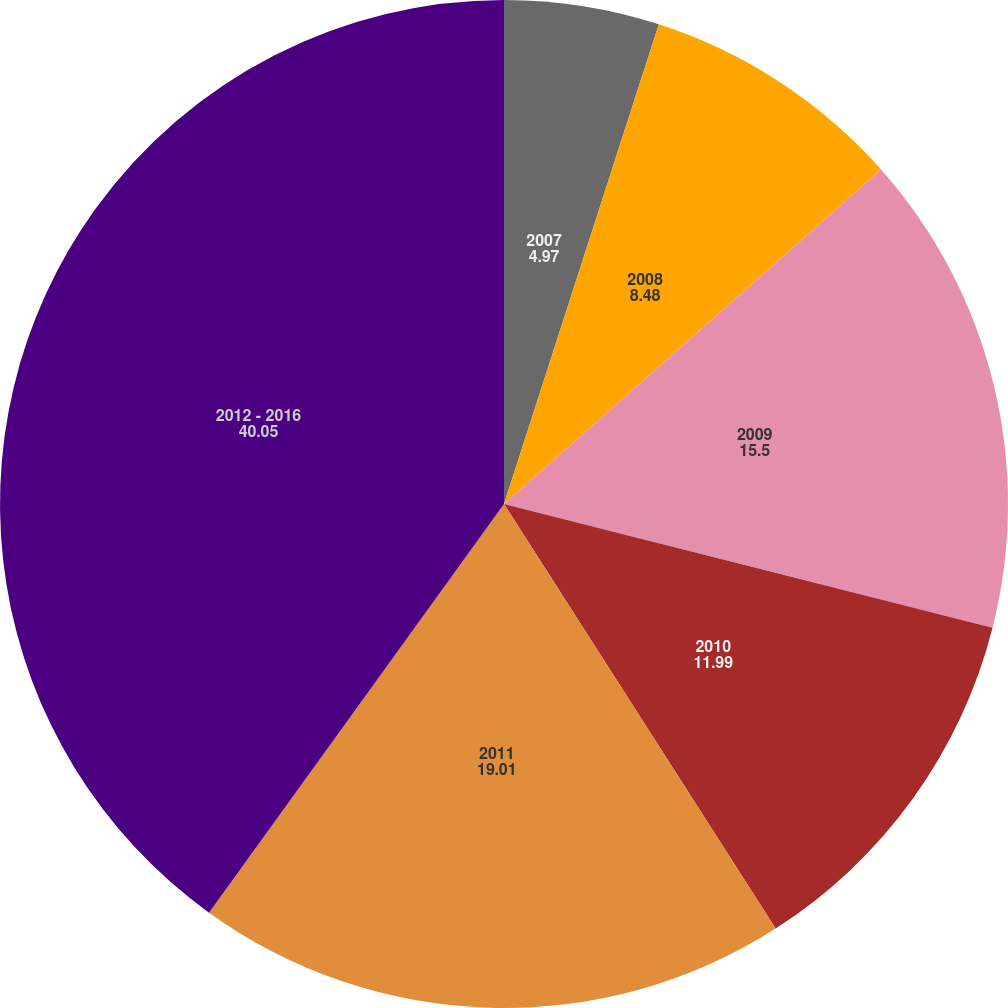Convert chart to OTSL. <chart><loc_0><loc_0><loc_500><loc_500><pie_chart><fcel>2007<fcel>2008<fcel>2009<fcel>2010<fcel>2011<fcel>2012 - 2016<nl><fcel>4.97%<fcel>8.48%<fcel>15.5%<fcel>11.99%<fcel>19.01%<fcel>40.05%<nl></chart> 